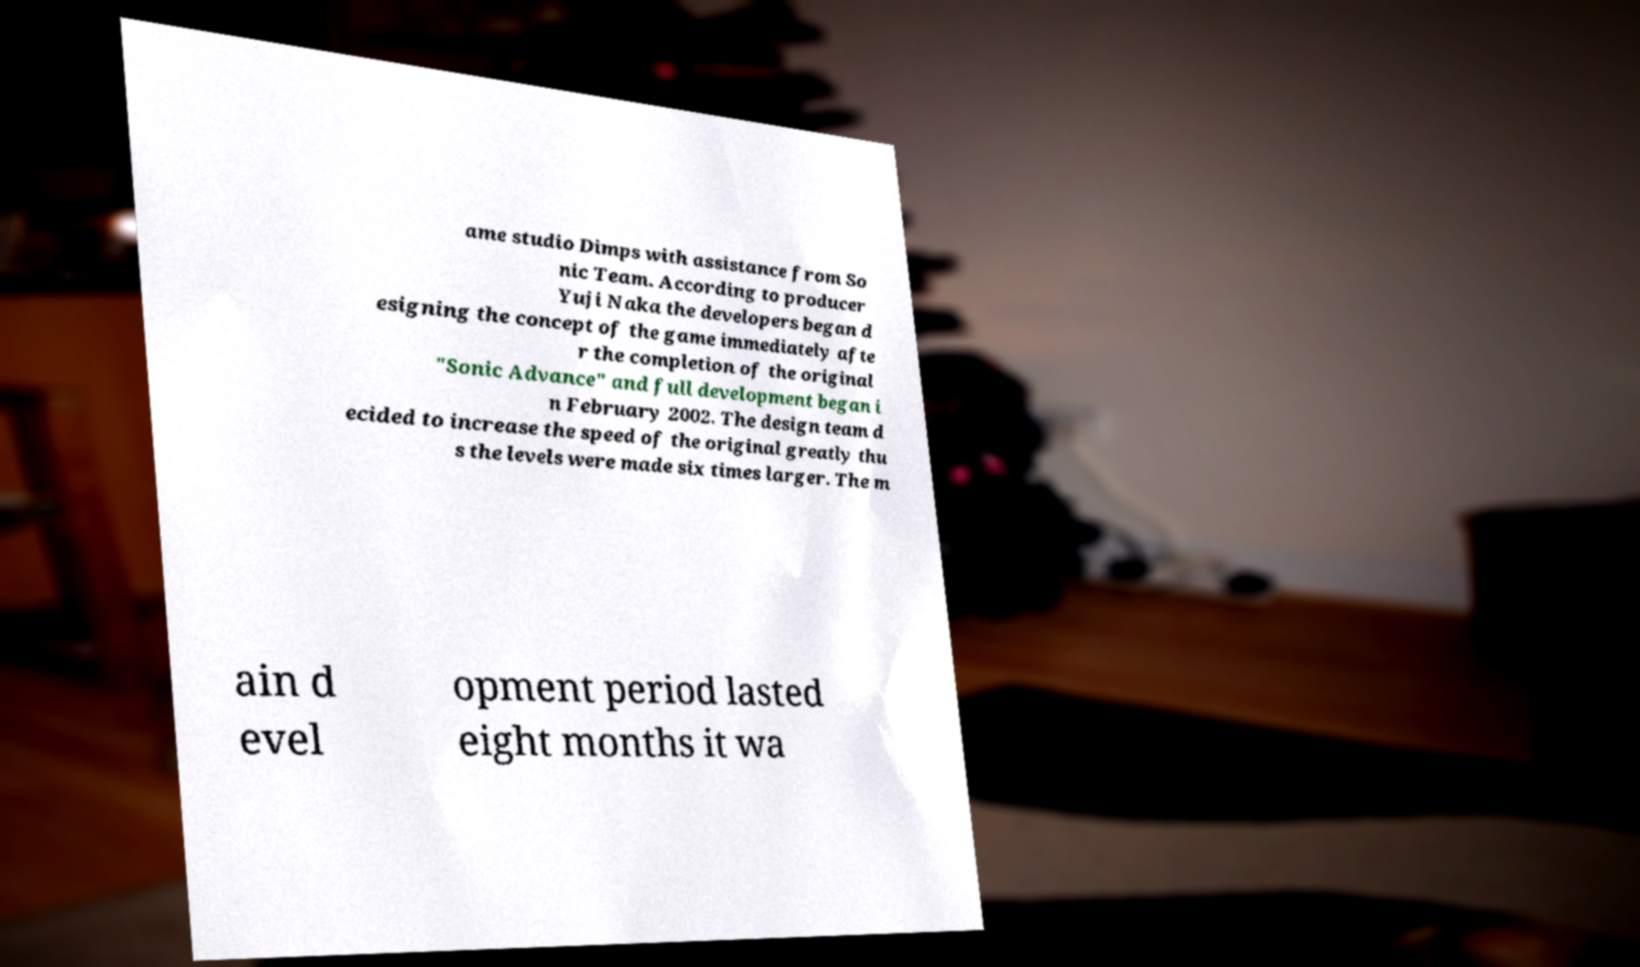For documentation purposes, I need the text within this image transcribed. Could you provide that? ame studio Dimps with assistance from So nic Team. According to producer Yuji Naka the developers began d esigning the concept of the game immediately afte r the completion of the original "Sonic Advance" and full development began i n February 2002. The design team d ecided to increase the speed of the original greatly thu s the levels were made six times larger. The m ain d evel opment period lasted eight months it wa 